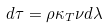<formula> <loc_0><loc_0><loc_500><loc_500>d \tau = \rho \kappa _ { T } \nu d \lambda</formula> 